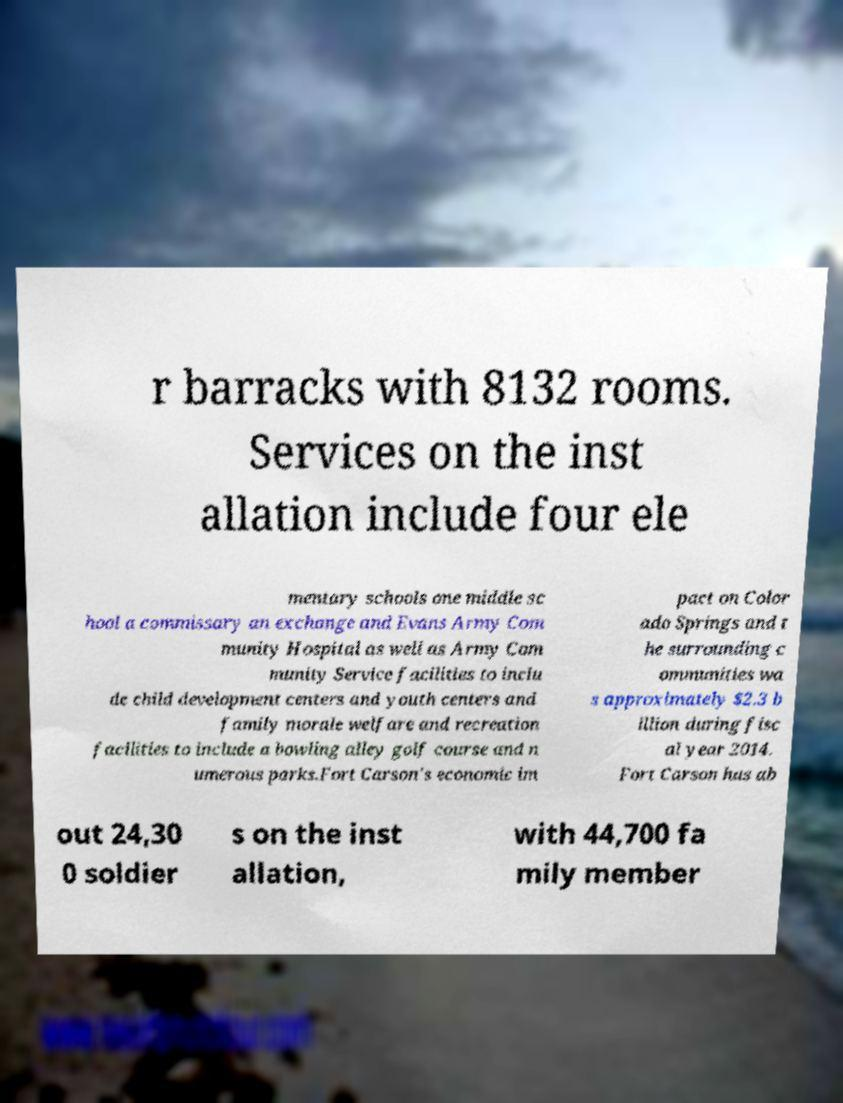Could you extract and type out the text from this image? r barracks with 8132 rooms. Services on the inst allation include four ele mentary schools one middle sc hool a commissary an exchange and Evans Army Com munity Hospital as well as Army Com munity Service facilities to inclu de child development centers and youth centers and family morale welfare and recreation facilities to include a bowling alley golf course and n umerous parks.Fort Carson's economic im pact on Color ado Springs and t he surrounding c ommunities wa s approximately $2.3 b illion during fisc al year 2014. Fort Carson has ab out 24,30 0 soldier s on the inst allation, with 44,700 fa mily member 